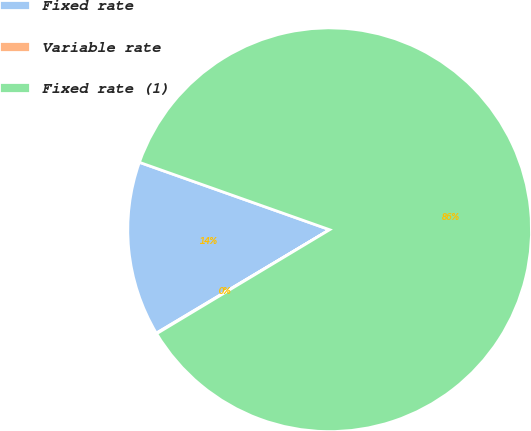Convert chart to OTSL. <chart><loc_0><loc_0><loc_500><loc_500><pie_chart><fcel>Fixed rate<fcel>Variable rate<fcel>Fixed rate (1)<nl><fcel>13.98%<fcel>0.05%<fcel>85.96%<nl></chart> 